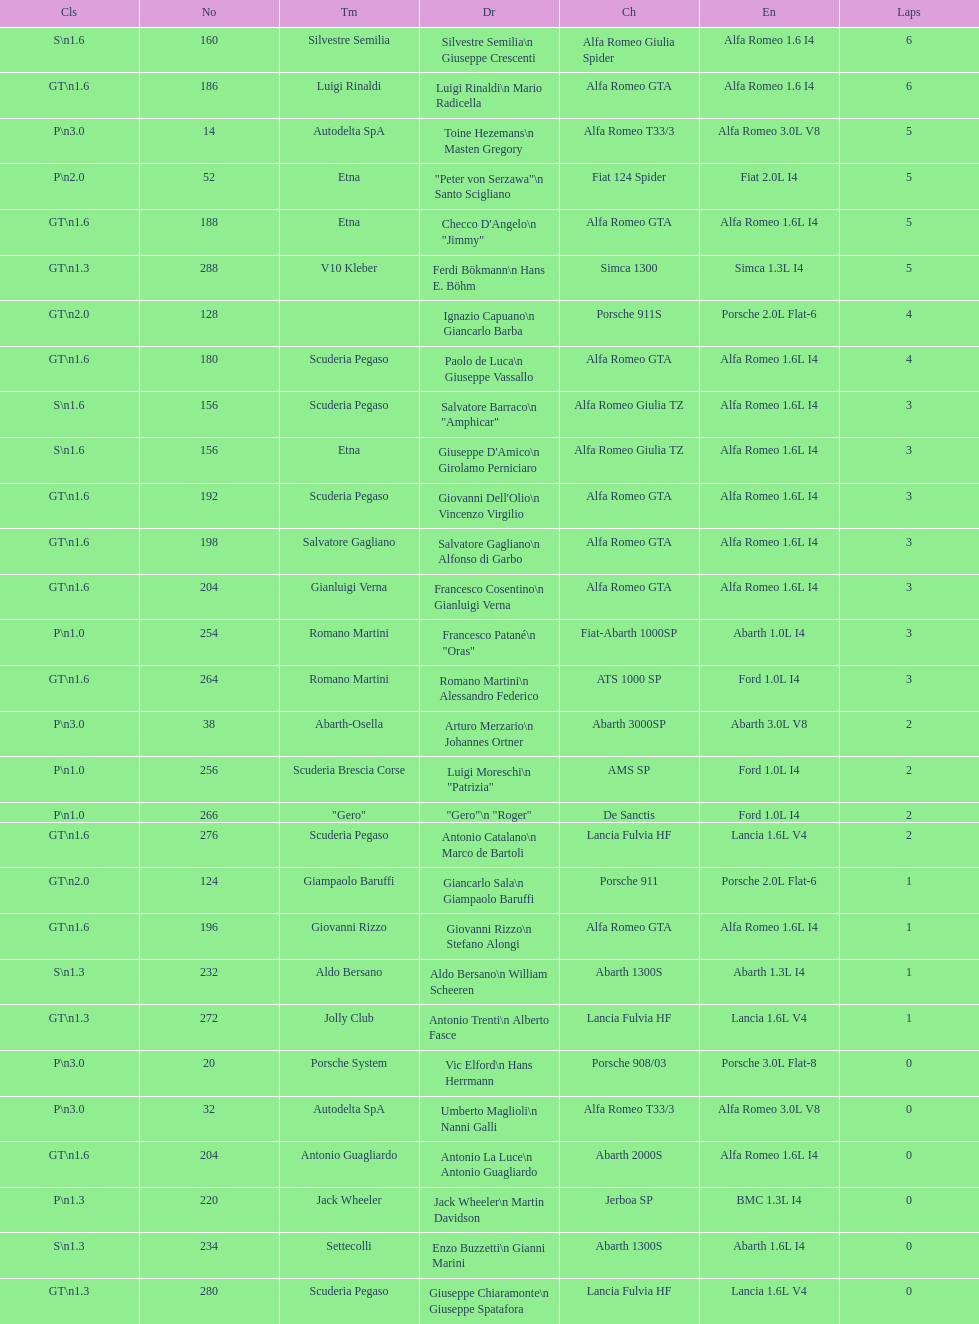What is the class that follows s GT 1.6. 